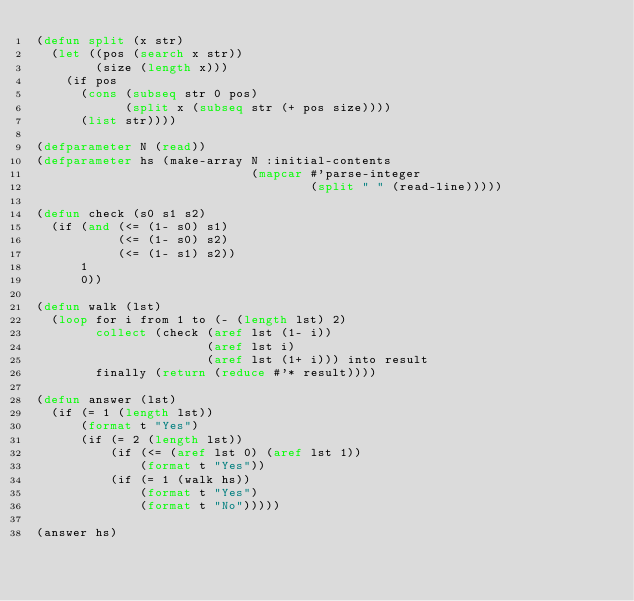Convert code to text. <code><loc_0><loc_0><loc_500><loc_500><_Lisp_>(defun split (x str)
  (let ((pos (search x str))
        (size (length x)))
    (if pos
      (cons (subseq str 0 pos)
            (split x (subseq str (+ pos size))))
      (list str))))
 
(defparameter N (read))
(defparameter hs (make-array N :initial-contents
                             (mapcar #'parse-integer
                                     (split " " (read-line)))))

(defun check (s0 s1 s2)
  (if (and (<= (1- s0) s1)
           (<= (1- s0) s2)
           (<= (1- s1) s2))
      1
      0))
 
(defun walk (lst)
  (loop for i from 1 to (- (length lst) 2)
        collect (check (aref lst (1- i))
                       (aref lst i)
                       (aref lst (1+ i))) into result
        finally (return (reduce #'* result))))
 
(defun answer (lst)
  (if (= 1 (length lst))
      (format t "Yes")
      (if (= 2 (length lst))
          (if (<= (aref lst 0) (aref lst 1))
              (format t "Yes"))
          (if (= 1 (walk hs))
              (format t "Yes")
              (format t "No")))))
 
(answer hs)</code> 